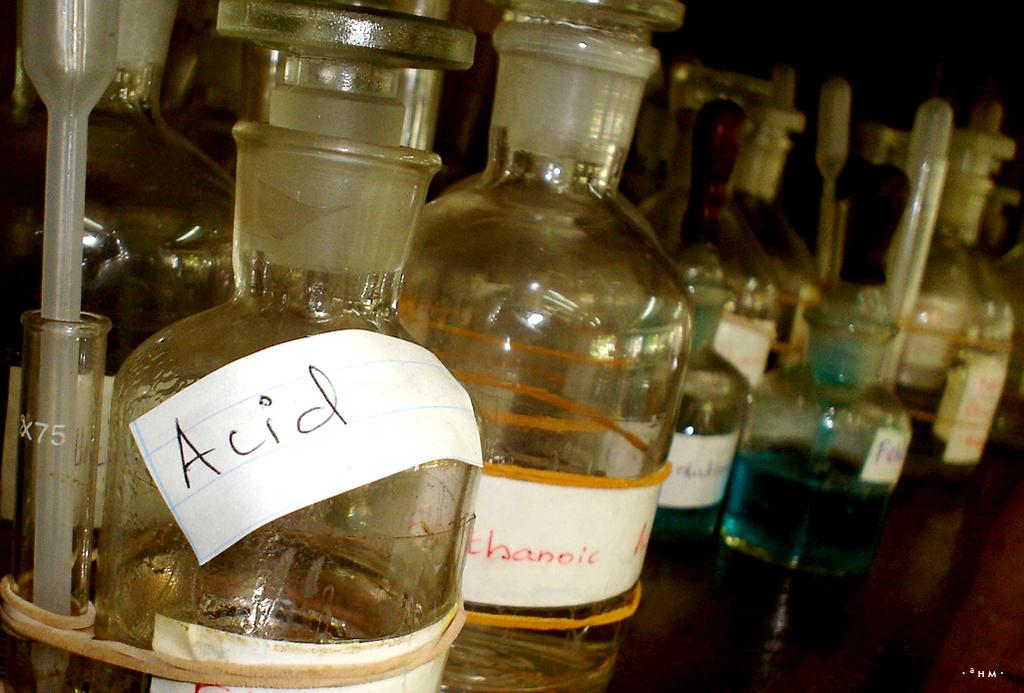<image>
Summarize the visual content of the image. bottles in a row on a counter with one of them labeled as 'acid' 